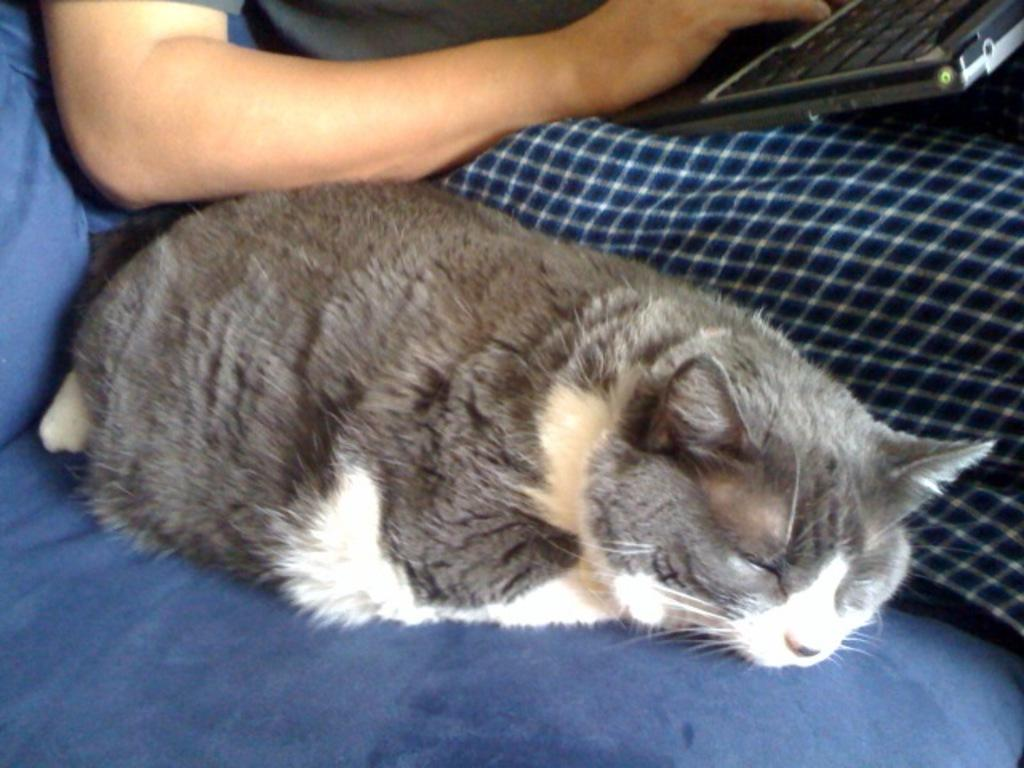What type of animal is in the image? There is a cat in the image. Who or what else is in the image? There is a person in the image. What is the color of the cloth that the cat and person are on? Both the cat and person are on a blue cloth. What electronic device is visible in the image? There is a keyboard visible in the top right corner of the image. What type of berry is the cat eating in the image? There is no berry present in the image, and the cat is not eating anything. 